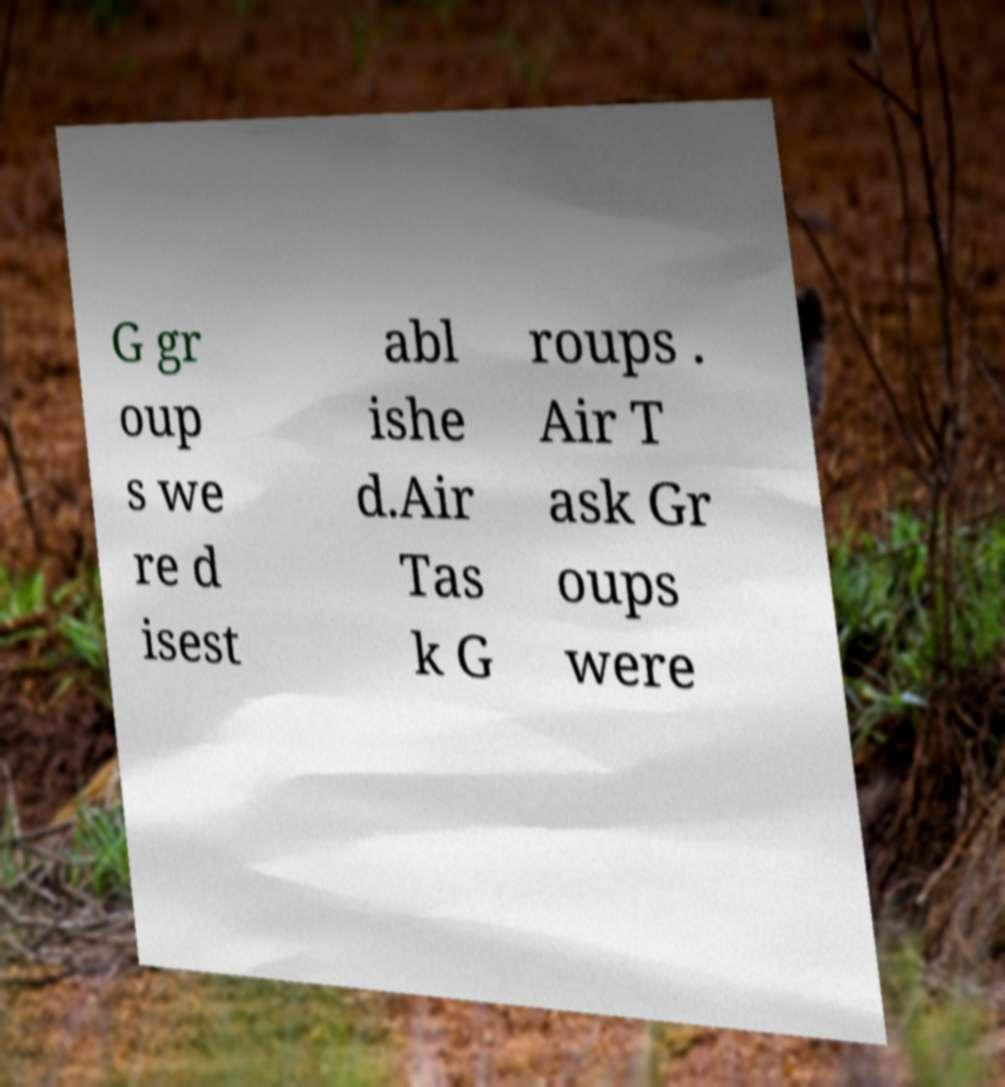Can you accurately transcribe the text from the provided image for me? G gr oup s we re d isest abl ishe d.Air Tas k G roups . Air T ask Gr oups were 